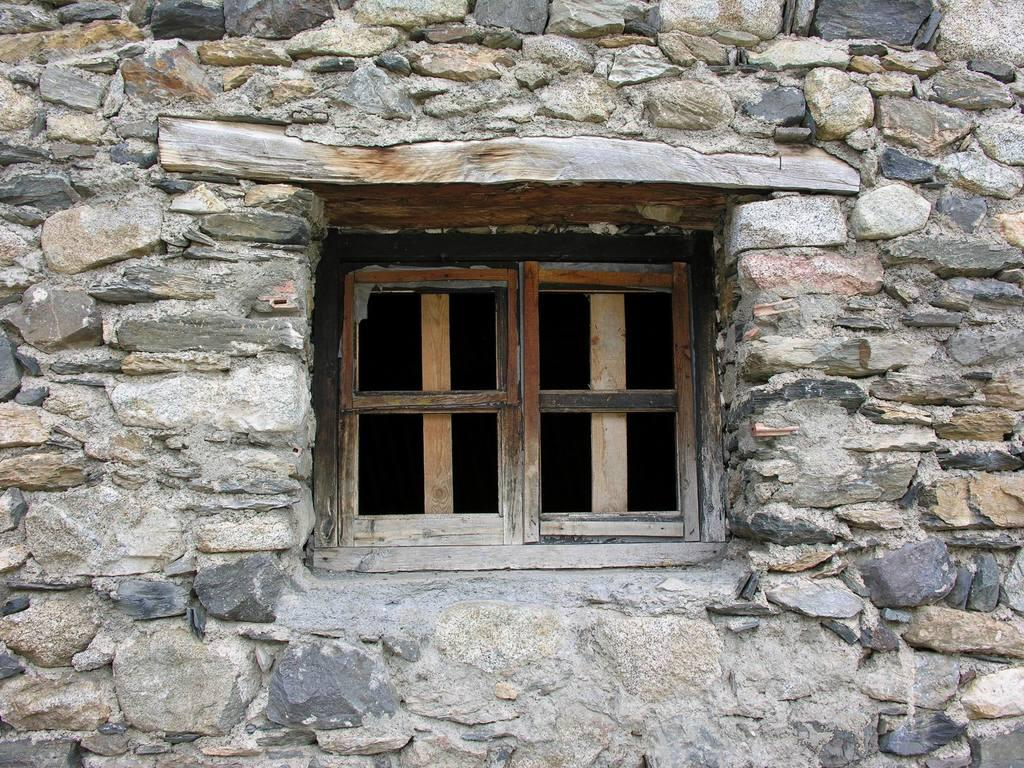What type of structure can be seen in the image? There is a wall in the image. Can you describe any architectural features in the image? There is a window frame in the image. What type of soup is being served in the window frame? There is no soup present in the image, as it only features a wall and a window frame. 